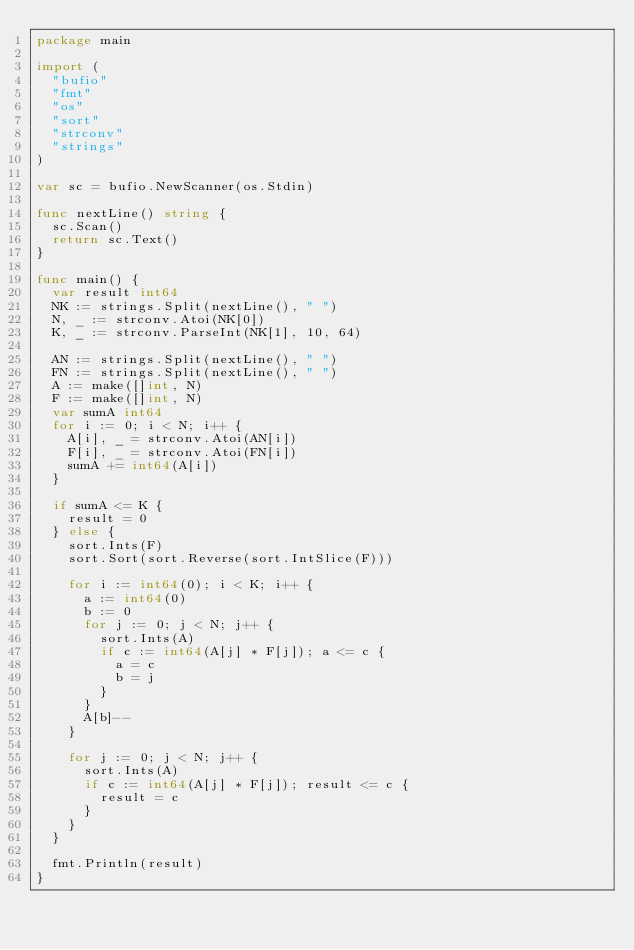<code> <loc_0><loc_0><loc_500><loc_500><_Go_>package main

import (
	"bufio"
	"fmt"
	"os"
	"sort"
	"strconv"
	"strings"
)

var sc = bufio.NewScanner(os.Stdin)

func nextLine() string {
	sc.Scan()
	return sc.Text()
}

func main() {
	var result int64
	NK := strings.Split(nextLine(), " ")
	N, _ := strconv.Atoi(NK[0])
	K, _ := strconv.ParseInt(NK[1], 10, 64)

	AN := strings.Split(nextLine(), " ")
	FN := strings.Split(nextLine(), " ")
	A := make([]int, N)
	F := make([]int, N)
	var sumA int64
	for i := 0; i < N; i++ {
		A[i], _ = strconv.Atoi(AN[i])
		F[i], _ = strconv.Atoi(FN[i])
		sumA += int64(A[i])
	}

	if sumA <= K {
		result = 0
	} else {
		sort.Ints(F)
		sort.Sort(sort.Reverse(sort.IntSlice(F)))

		for i := int64(0); i < K; i++ {
			a := int64(0)
			b := 0
			for j := 0; j < N; j++ {
				sort.Ints(A)
				if c := int64(A[j] * F[j]); a <= c {
					a = c
					b = j
				}
			}
			A[b]--
		}

		for j := 0; j < N; j++ {
			sort.Ints(A)
			if c := int64(A[j] * F[j]); result <= c {
				result = c
			}
		}
	}

	fmt.Println(result)
}
</code> 